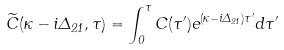Convert formula to latex. <formula><loc_0><loc_0><loc_500><loc_500>\widetilde { C } ( \kappa - i \Delta _ { 2 1 } , \tau ) = \int _ { 0 } ^ { \tau } C ( \tau ^ { \prime } ) e ^ { ( \kappa - i \Delta _ { 2 1 } ) \tau ^ { \prime } } d \tau ^ { \prime }</formula> 